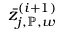<formula> <loc_0><loc_0><loc_500><loc_500>\bar { z } _ { j , \mathbb { P } , w } ^ { ( i + 1 ) }</formula> 